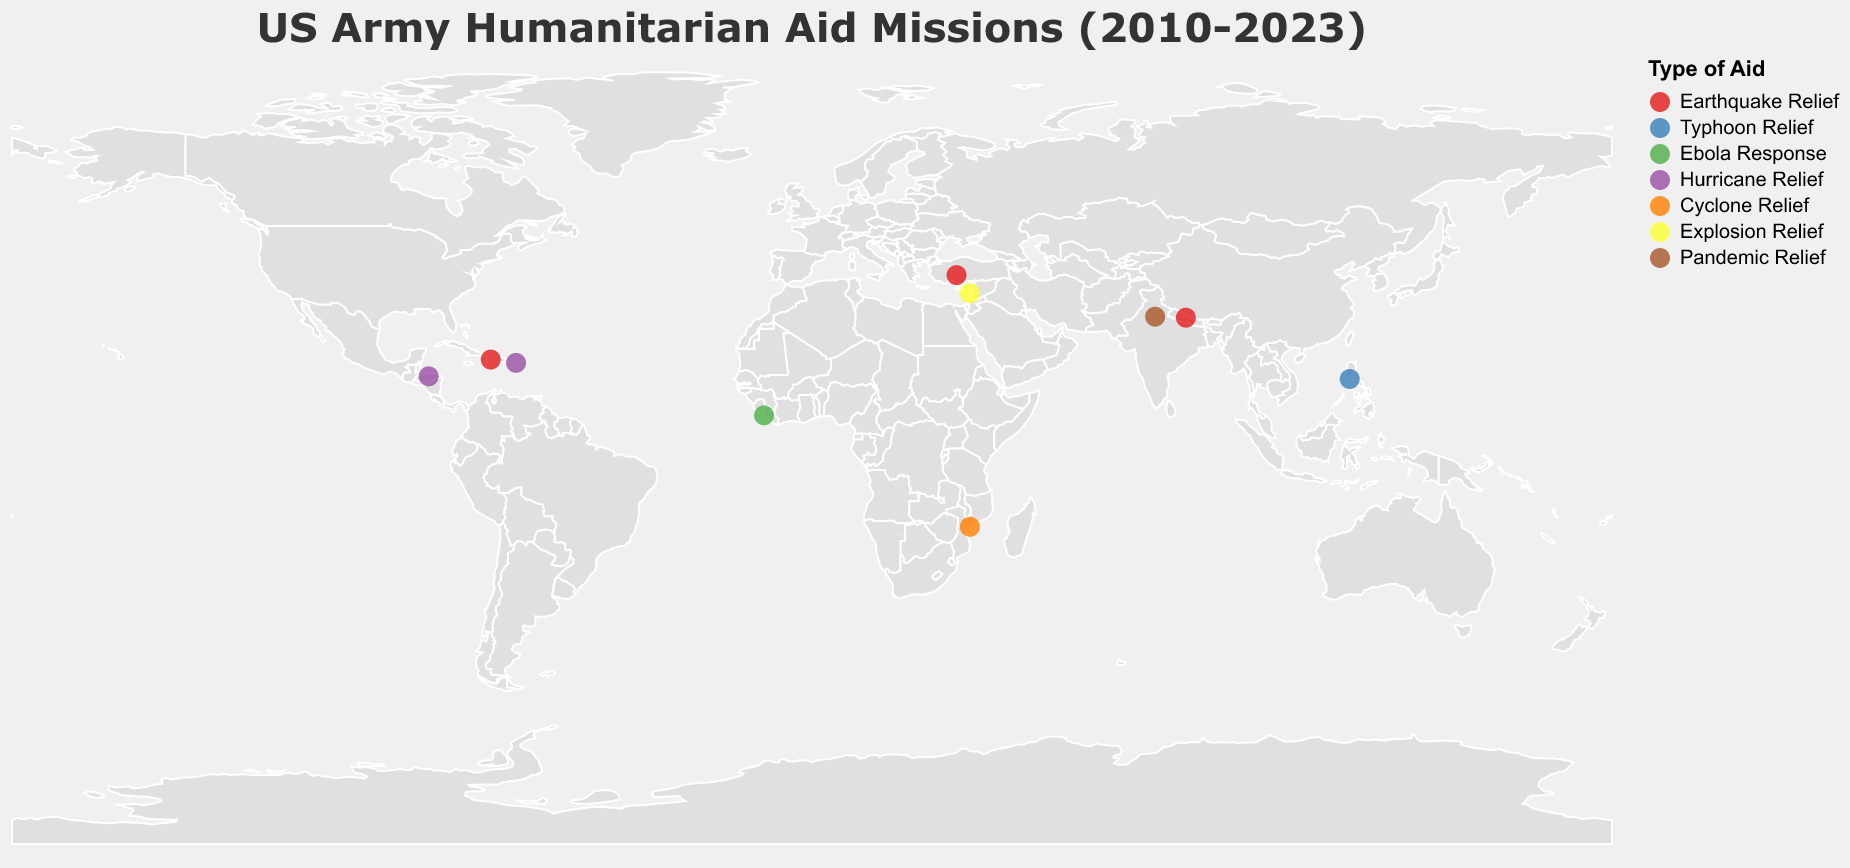What is the title of the figure? The title is located at the top section of the figure, displaying the main subject or focus of the visual representation.
Answer: US Army Humanitarian Aid Missions (2010-2023) How many distinct locations are represented in the figure? The figure represents each location with a circle. By counting these circles on the geographic plot, you can determine the number of distinct locations.
Answer: 10 Which operation provided Earthquake Relief in 2010? By examining the tooltip or legend information tied to each data point (circles), we can identify the operation associated with Earthquake Relief in 2010.
Answer: Operation Unified Response What type of aid was provided in Liberia in 2014? Hover over or reference the circle plotted at the geographic coordinates representing Liberia (6.4281, -10.7969) and check the tooltip or the legend to find the type of aid.
Answer: Ebola Response Which type of aid appears most frequently in the figure? Observing the color-coded legend and counting the number of circles corresponding to each Aid_Type will help identify the most frequent type of aid.
Answer: Earthquake Relief Between 2015 and 2020, how many operations were related to hurricane relief? Sum the number of circles representing 'Hurricane Relief' within the year range of 2015 to 2020 by observing the tooltips or annotations tied to each data point.
Answer: 2 Which operation occurred closest to the equator? By comparing the absolute Latitude values of all the operations, identify the one with the latitude closest to 0 degrees.
Answer: Operation United Assistance (Liberia, 6.4281 latitude) In which year did most diverse types of aid missions occur? Tally up the different typesof 'Aid_Type' by year in the figure, noting the maximum diversity, meaning the year with the most varied 'Aid_Type' categories.
Answer: 2020 Compare the geographical spread of earthquake relief operations to hurricane relief operations. Which type covered more regions? Count the number of unique circles (locations) for each aid type: 'Earthquake Relief' and 'Hurricane Relief,' then compare these numbers.
Answer: Earthquake Relief (4 operations) covered more regions than Hurricane Relief (2 operations) Identify the operation provided in Turkey for earthquake relief. By observing the figure, look for a circle located in Turkey (approximate geo-coordinates 37.9687, 32.5214) and check the tooltip for details specific to the operation and aid type.
Answer: Earthquake Response 